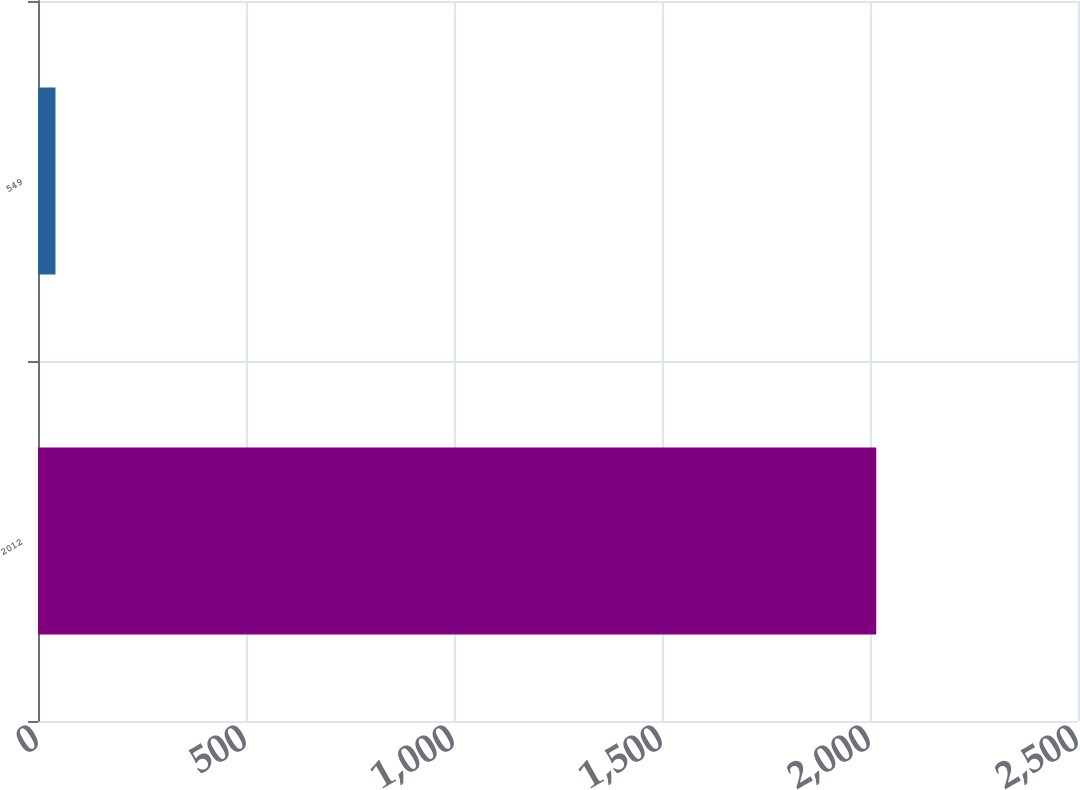Convert chart to OTSL. <chart><loc_0><loc_0><loc_500><loc_500><bar_chart><fcel>2012<fcel>549<nl><fcel>2015<fcel>42<nl></chart> 